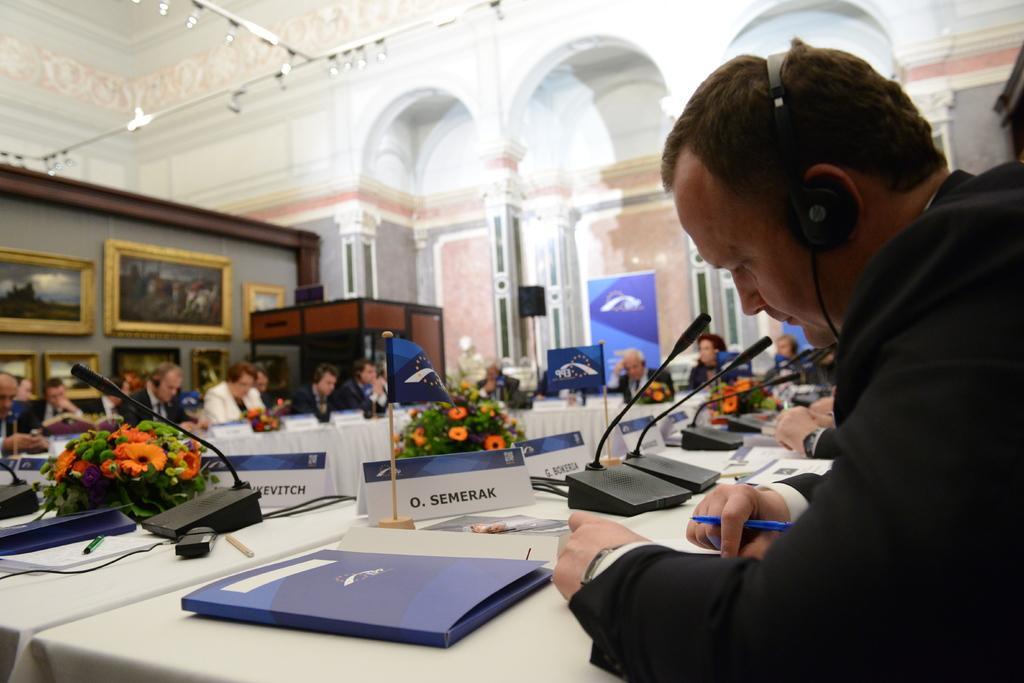Describe this image in one or two sentences. In this picture there are few persons sitting and there is a table in front of them which has few mic,flags,books and some other objects on it and there are few photo frames attached to the wall in the background and there are few lights above them. 